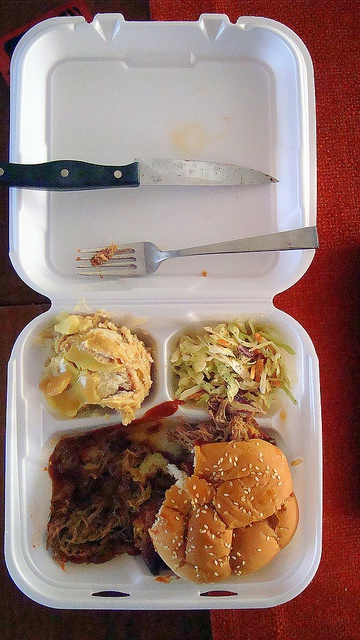Describe the objects in this image and their specific colors. I can see sandwich in black, brown, orange, and maroon tones, knife in black, darkgray, navy, and lightgray tones, and fork in black, darkgray, and gray tones in this image. 